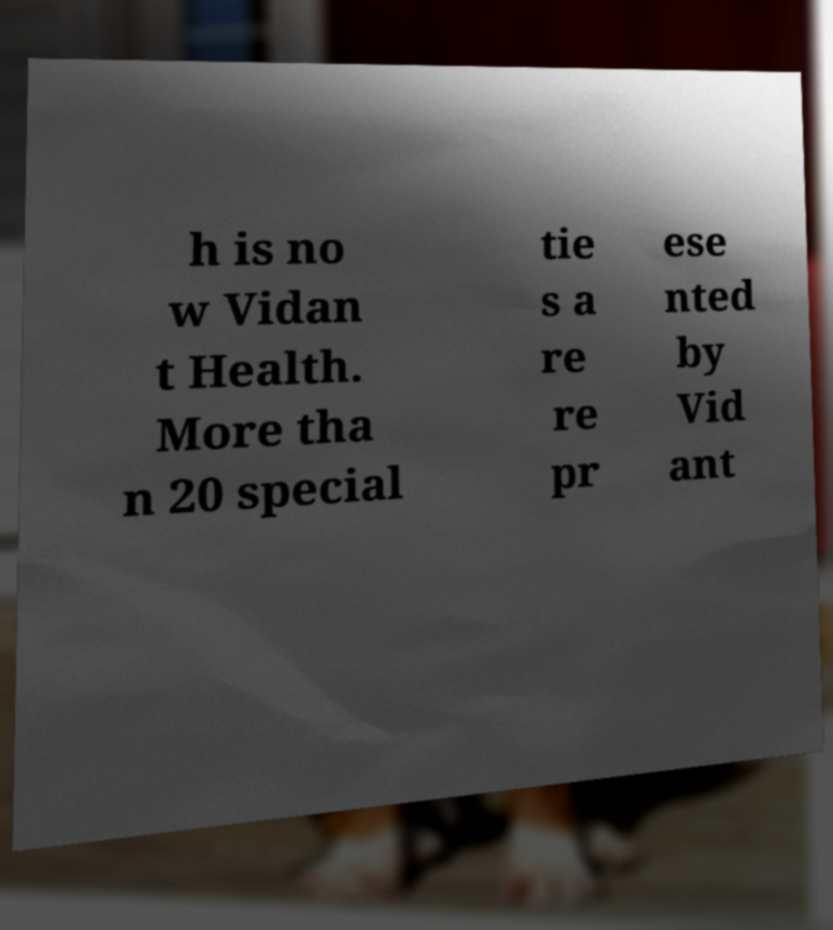Could you assist in decoding the text presented in this image and type it out clearly? h is no w Vidan t Health. More tha n 20 special tie s a re re pr ese nted by Vid ant 